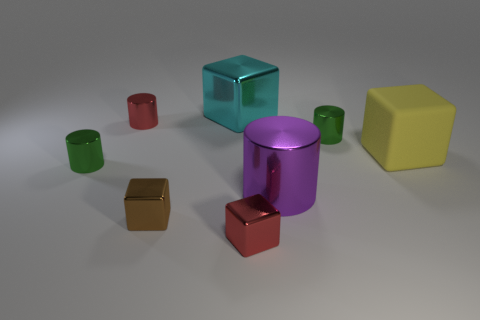Subtract all purple cylinders. How many cylinders are left? 3 Add 1 red metal blocks. How many objects exist? 9 Subtract all purple cylinders. How many cylinders are left? 3 Subtract all yellow spheres. How many green cylinders are left? 2 Subtract all big cubes. Subtract all tiny green things. How many objects are left? 4 Add 5 large purple metallic cylinders. How many large purple metallic cylinders are left? 6 Add 5 small gray matte cubes. How many small gray matte cubes exist? 5 Subtract 1 green cylinders. How many objects are left? 7 Subtract 2 cubes. How many cubes are left? 2 Subtract all red cubes. Subtract all green cylinders. How many cubes are left? 3 